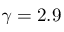<formula> <loc_0><loc_0><loc_500><loc_500>\gamma = 2 . 9</formula> 